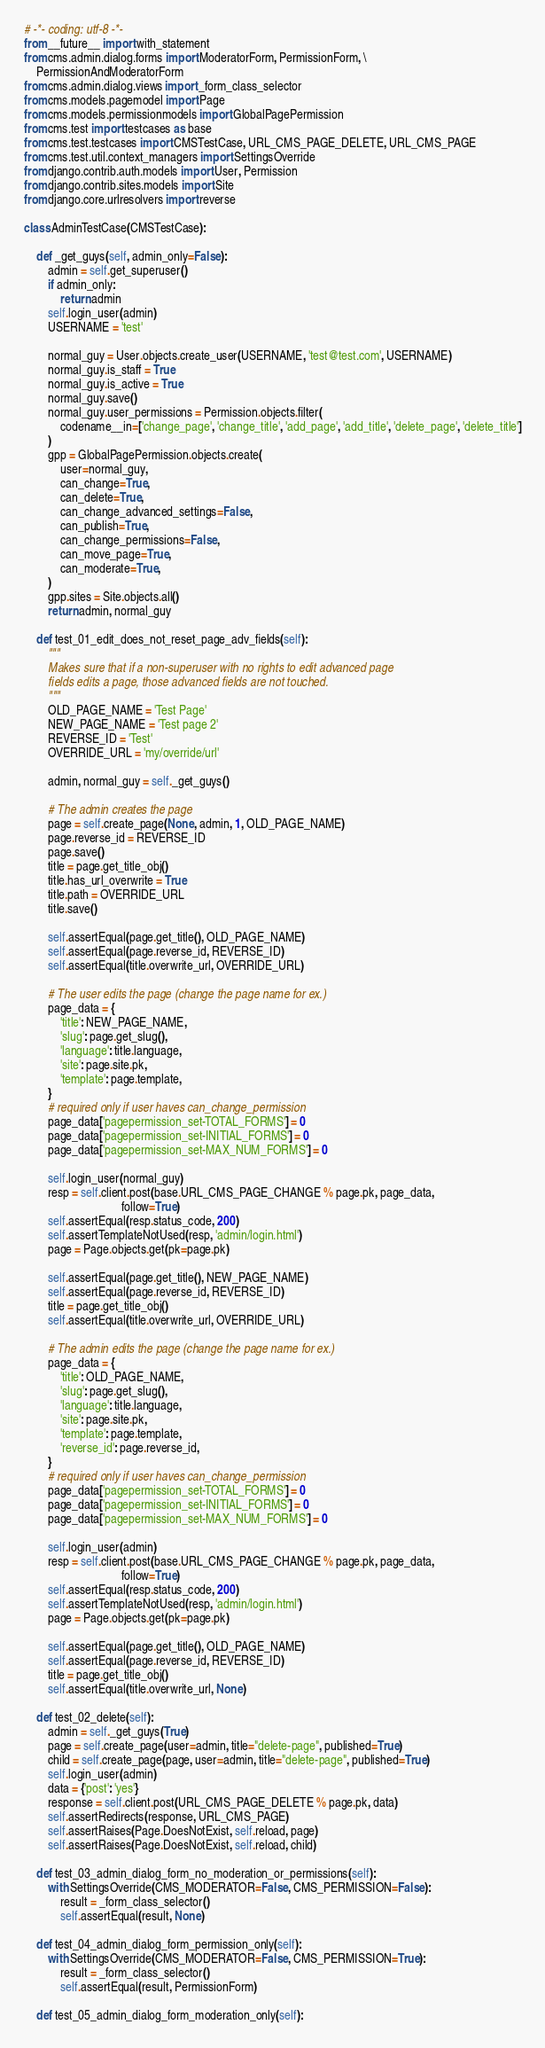Convert code to text. <code><loc_0><loc_0><loc_500><loc_500><_Python_># -*- coding: utf-8 -*-
from __future__ import with_statement
from cms.admin.dialog.forms import ModeratorForm, PermissionForm, \
    PermissionAndModeratorForm
from cms.admin.dialog.views import _form_class_selector
from cms.models.pagemodel import Page
from cms.models.permissionmodels import GlobalPagePermission
from cms.test import testcases as base
from cms.test.testcases import CMSTestCase, URL_CMS_PAGE_DELETE, URL_CMS_PAGE
from cms.test.util.context_managers import SettingsOverride
from django.contrib.auth.models import User, Permission
from django.contrib.sites.models import Site
from django.core.urlresolvers import reverse

class AdminTestCase(CMSTestCase):
    
    def _get_guys(self, admin_only=False):
        admin = self.get_superuser()
        if admin_only:
            return admin
        self.login_user(admin)
        USERNAME = 'test'
        
        normal_guy = User.objects.create_user(USERNAME, 'test@test.com', USERNAME)
        normal_guy.is_staff = True
        normal_guy.is_active = True
        normal_guy.save()
        normal_guy.user_permissions = Permission.objects.filter(
            codename__in=['change_page', 'change_title', 'add_page', 'add_title', 'delete_page', 'delete_title']
        )
        gpp = GlobalPagePermission.objects.create(
            user=normal_guy,
            can_change=True,
            can_delete=True,
            can_change_advanced_settings=False,
            can_publish=True,
            can_change_permissions=False,
            can_move_page=True,
            can_moderate=True,
        )
        gpp.sites = Site.objects.all()
        return admin, normal_guy
    
    def test_01_edit_does_not_reset_page_adv_fields(self):
        """
        Makes sure that if a non-superuser with no rights to edit advanced page
        fields edits a page, those advanced fields are not touched.
        """
        OLD_PAGE_NAME = 'Test Page'
        NEW_PAGE_NAME = 'Test page 2'
        REVERSE_ID = 'Test'
        OVERRIDE_URL = 'my/override/url'
        
        admin, normal_guy = self._get_guys()
        
        # The admin creates the page
        page = self.create_page(None, admin, 1, OLD_PAGE_NAME)
        page.reverse_id = REVERSE_ID
        page.save()
        title = page.get_title_obj()
        title.has_url_overwrite = True
        title.path = OVERRIDE_URL
        title.save()
        
        self.assertEqual(page.get_title(), OLD_PAGE_NAME)
        self.assertEqual(page.reverse_id, REVERSE_ID)
        self.assertEqual(title.overwrite_url, OVERRIDE_URL)
        
        # The user edits the page (change the page name for ex.)
        page_data = {
            'title': NEW_PAGE_NAME, 
            'slug': page.get_slug(), 
            'language': title.language,
            'site': page.site.pk, 
            'template': page.template,
        }
        # required only if user haves can_change_permission
        page_data['pagepermission_set-TOTAL_FORMS'] = 0
        page_data['pagepermission_set-INITIAL_FORMS'] = 0
        page_data['pagepermission_set-MAX_NUM_FORMS'] = 0
        
        self.login_user(normal_guy)
        resp = self.client.post(base.URL_CMS_PAGE_CHANGE % page.pk, page_data, 
                                follow=True)
        self.assertEqual(resp.status_code, 200)
        self.assertTemplateNotUsed(resp, 'admin/login.html')
        page = Page.objects.get(pk=page.pk)
        
        self.assertEqual(page.get_title(), NEW_PAGE_NAME)
        self.assertEqual(page.reverse_id, REVERSE_ID)
        title = page.get_title_obj()
        self.assertEqual(title.overwrite_url, OVERRIDE_URL)
        
        # The admin edits the page (change the page name for ex.)
        page_data = {
            'title': OLD_PAGE_NAME, 
            'slug': page.get_slug(), 
            'language': title.language,
            'site': page.site.pk, 
            'template': page.template,
            'reverse_id': page.reverse_id,
        }
        # required only if user haves can_change_permission
        page_data['pagepermission_set-TOTAL_FORMS'] = 0
        page_data['pagepermission_set-INITIAL_FORMS'] = 0
        page_data['pagepermission_set-MAX_NUM_FORMS'] = 0
        
        self.login_user(admin)
        resp = self.client.post(base.URL_CMS_PAGE_CHANGE % page.pk, page_data, 
                                follow=True)
        self.assertEqual(resp.status_code, 200)
        self.assertTemplateNotUsed(resp, 'admin/login.html')
        page = Page.objects.get(pk=page.pk)
        
        self.assertEqual(page.get_title(), OLD_PAGE_NAME)
        self.assertEqual(page.reverse_id, REVERSE_ID)
        title = page.get_title_obj()
        self.assertEqual(title.overwrite_url, None)

    def test_02_delete(self):
        admin = self._get_guys(True)
        page = self.create_page(user=admin, title="delete-page", published=True)
        child = self.create_page(page, user=admin, title="delete-page", published=True)
        self.login_user(admin)
        data = {'post': 'yes'}
        response = self.client.post(URL_CMS_PAGE_DELETE % page.pk, data)
        self.assertRedirects(response, URL_CMS_PAGE)
        self.assertRaises(Page.DoesNotExist, self.reload, page)
        self.assertRaises(Page.DoesNotExist, self.reload, child)
        
    def test_03_admin_dialog_form_no_moderation_or_permissions(self):
        with SettingsOverride(CMS_MODERATOR=False, CMS_PERMISSION=False):
            result = _form_class_selector()
            self.assertEqual(result, None)
            
    def test_04_admin_dialog_form_permission_only(self):
        with SettingsOverride(CMS_MODERATOR=False, CMS_PERMISSION=True):
            result = _form_class_selector()
            self.assertEqual(result, PermissionForm)
            
    def test_05_admin_dialog_form_moderation_only(self):</code> 